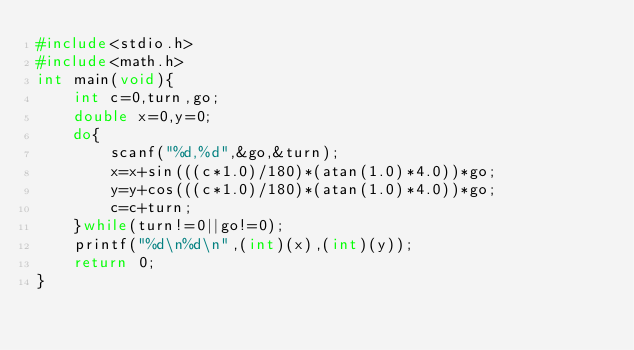<code> <loc_0><loc_0><loc_500><loc_500><_C_>#include<stdio.h>
#include<math.h>
int main(void){
	int c=0,turn,go;
	double x=0,y=0;
	do{
		scanf("%d,%d",&go,&turn);
		x=x+sin(((c*1.0)/180)*(atan(1.0)*4.0))*go;
		y=y+cos(((c*1.0)/180)*(atan(1.0)*4.0))*go;
		c=c+turn;
	}while(turn!=0||go!=0);
	printf("%d\n%d\n",(int)(x),(int)(y));
	return 0;
}</code> 